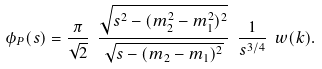<formula> <loc_0><loc_0><loc_500><loc_500>\phi _ { P } ( s ) = \frac { \pi } { \sqrt { 2 } } \ \frac { \sqrt { s ^ { 2 } - ( m _ { 2 } ^ { 2 } - m _ { 1 } ^ { 2 } ) ^ { 2 } } } { \sqrt { s - ( m _ { 2 } - m _ { 1 } ) ^ { 2 } } } \ \frac { 1 } { s ^ { 3 / 4 } } \ w ( k ) .</formula> 